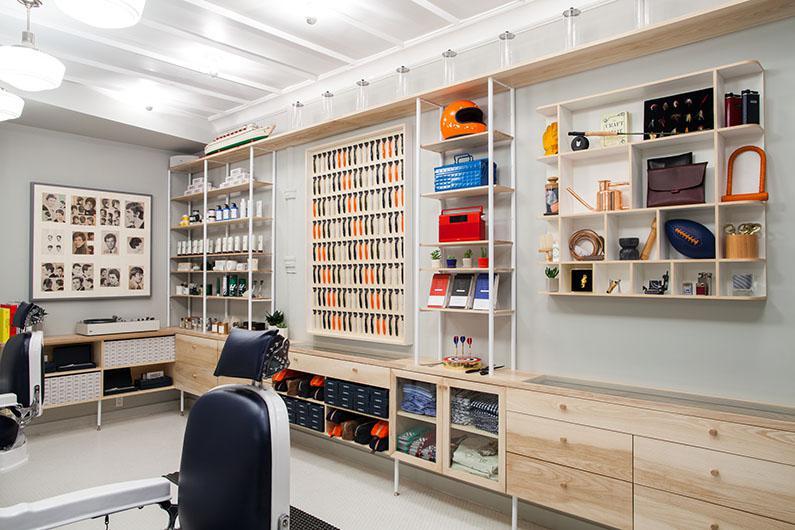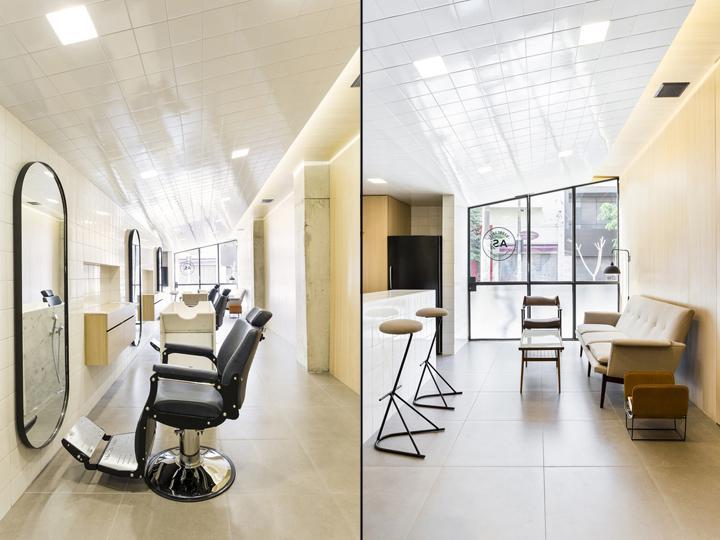The first image is the image on the left, the second image is the image on the right. Assess this claim about the two images: "There are mirrors on the right wall of the room in the image on the right". Correct or not? Answer yes or no. No. 